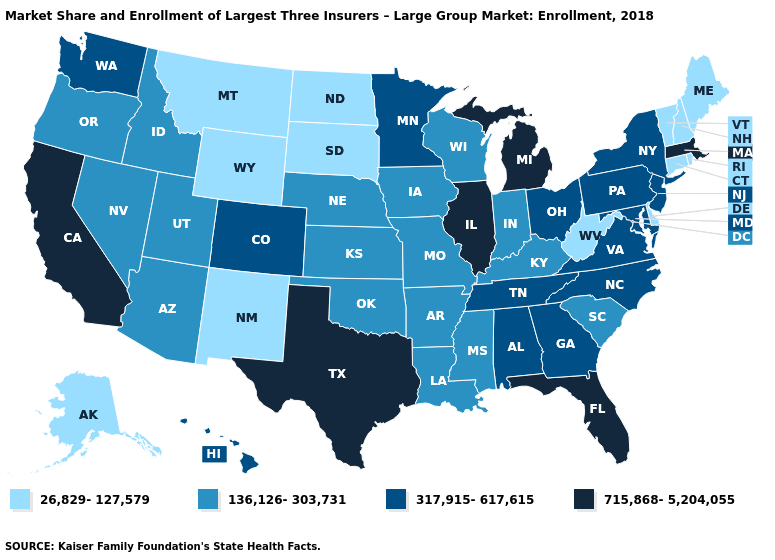Name the states that have a value in the range 26,829-127,579?
Keep it brief. Alaska, Connecticut, Delaware, Maine, Montana, New Hampshire, New Mexico, North Dakota, Rhode Island, South Dakota, Vermont, West Virginia, Wyoming. What is the value of Virginia?
Keep it brief. 317,915-617,615. Does South Dakota have the lowest value in the MidWest?
Short answer required. Yes. What is the value of Arizona?
Be succinct. 136,126-303,731. Among the states that border Virginia , which have the highest value?
Be succinct. Maryland, North Carolina, Tennessee. Name the states that have a value in the range 26,829-127,579?
Concise answer only. Alaska, Connecticut, Delaware, Maine, Montana, New Hampshire, New Mexico, North Dakota, Rhode Island, South Dakota, Vermont, West Virginia, Wyoming. Does Minnesota have a higher value than Kentucky?
Concise answer only. Yes. Name the states that have a value in the range 317,915-617,615?
Write a very short answer. Alabama, Colorado, Georgia, Hawaii, Maryland, Minnesota, New Jersey, New York, North Carolina, Ohio, Pennsylvania, Tennessee, Virginia, Washington. What is the value of New Mexico?
Keep it brief. 26,829-127,579. Name the states that have a value in the range 26,829-127,579?
Give a very brief answer. Alaska, Connecticut, Delaware, Maine, Montana, New Hampshire, New Mexico, North Dakota, Rhode Island, South Dakota, Vermont, West Virginia, Wyoming. Which states hav the highest value in the West?
Write a very short answer. California. Does California have the highest value in the West?
Give a very brief answer. Yes. Name the states that have a value in the range 317,915-617,615?
Answer briefly. Alabama, Colorado, Georgia, Hawaii, Maryland, Minnesota, New Jersey, New York, North Carolina, Ohio, Pennsylvania, Tennessee, Virginia, Washington. Which states hav the highest value in the Northeast?
Keep it brief. Massachusetts. 